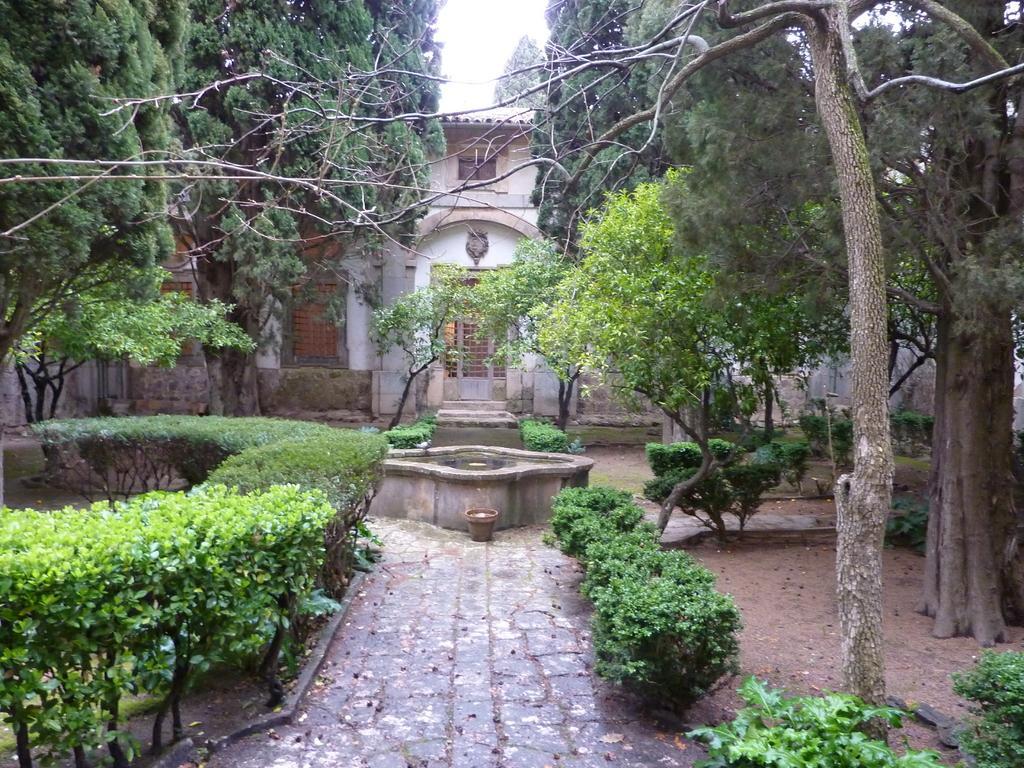Can you describe this image briefly? In this image, we can see some plants and trees. In the background, we can see a house. 